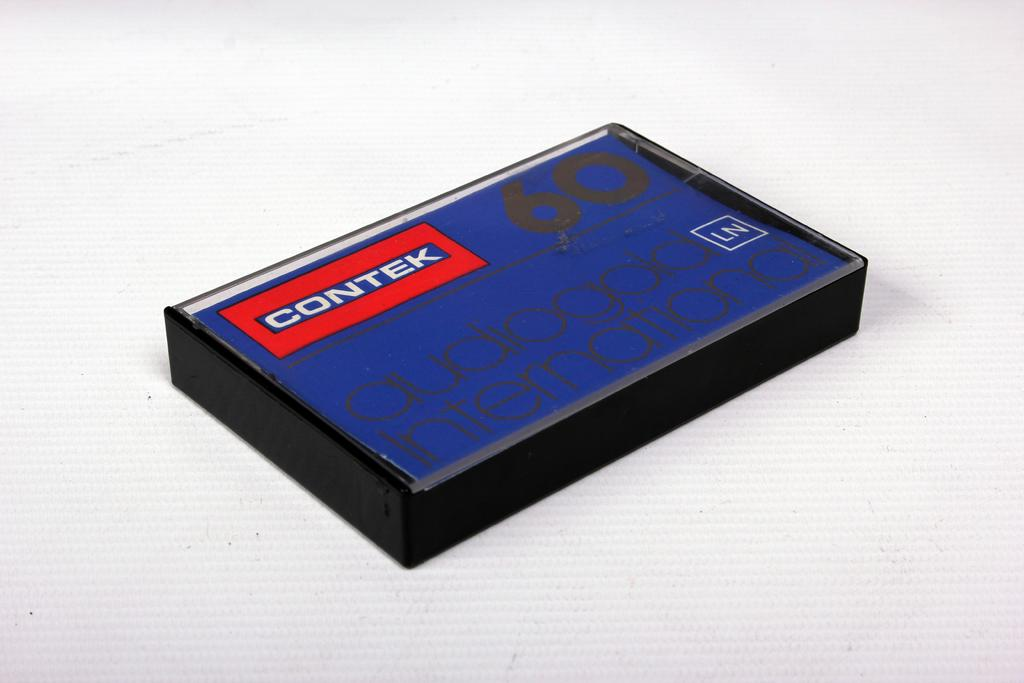<image>
Write a terse but informative summary of the picture. Contek 60 Audiogold International reads the front of this package. 